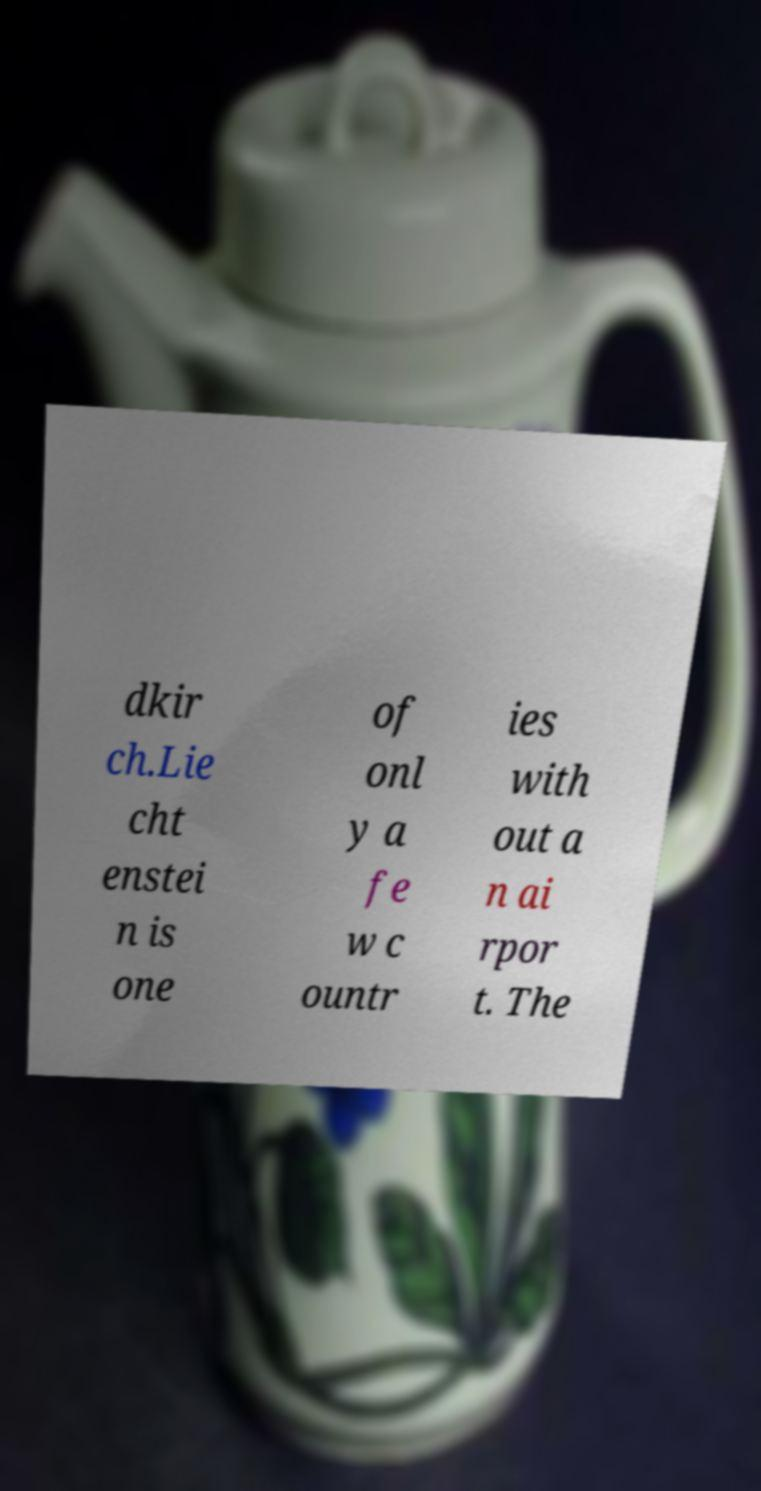Please read and relay the text visible in this image. What does it say? dkir ch.Lie cht enstei n is one of onl y a fe w c ountr ies with out a n ai rpor t. The 